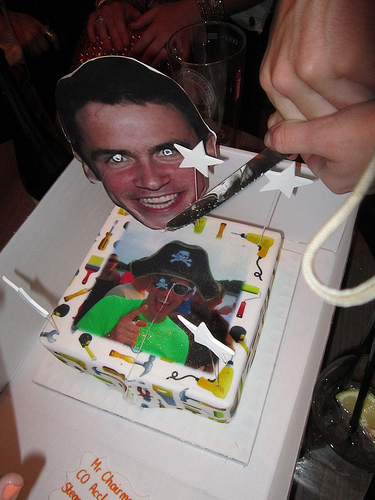Please provide a short description for this region: [0.27, 0.46, 0.58, 0.75]. The described section of the photo captures a dynamic moment where a person is gesturing animatedly with their finger, pointing towards an element in the image, perhaps highlighting a specific feature or playfully interacting with the cake's decorations. 